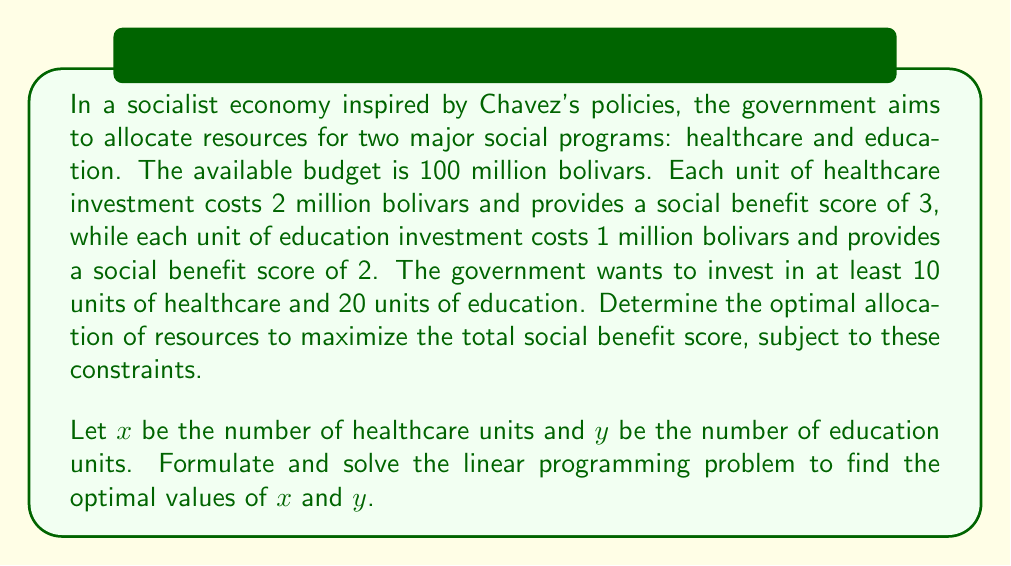Provide a solution to this math problem. To solve this linear programming problem, we need to follow these steps:

1. Formulate the objective function:
   Maximize $Z = 3x + 2y$ (total social benefit score)

2. Identify the constraints:
   a) Budget constraint: $2x + y \leq 100$ (total cost ≤ 100 million bolivars)
   b) Minimum healthcare units: $x \geq 10$
   c) Minimum education units: $y \geq 20$
   d) Non-negativity: $x \geq 0, y \geq 0$

3. Graph the feasible region:
   [asy]
   import graph;
   size(200);
   xaxis("x", 0, 55);
   yaxis("y", 0, 110);
   draw((0,100)--(50,0), blue);
   draw((10,0)--(10,100), red);
   draw((0,20)--(100,20), green);
   fill((10,20)--(10,80)--(45,20)--(10,20), lightgray);
   label("Feasible Region", (25,40));
   dot((10,80));
   dot((45,20));
   [/asy]

4. Identify the corner points of the feasible region:
   A (10, 80), B (45, 10), C (10, 20)

5. Evaluate the objective function at each corner point:
   A: $Z = 3(10) + 2(80) = 190$
   B: $Z = 3(45) + 2(10) = 155$
   C: $Z = 3(10) + 2(20) = 70$

6. The maximum value occurs at point A (10, 80)

Therefore, the optimal allocation is 10 units of healthcare and 80 units of education, resulting in a maximum social benefit score of 190.
Answer: The optimal allocation is $x = 10$ units of healthcare and $y = 80$ units of education, maximizing the total social benefit score at 190. 